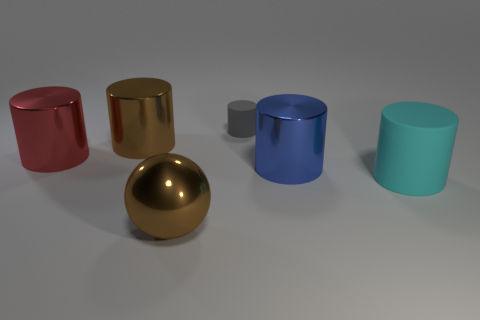The tiny gray rubber thing has what shape?
Offer a very short reply. Cylinder. What number of yellow balls are there?
Ensure brevity in your answer.  0. There is a large cylinder that is on the right side of the shiny cylinder that is right of the gray matte object; what color is it?
Provide a short and direct response. Cyan. There is a rubber cylinder that is the same size as the brown metal ball; what color is it?
Give a very brief answer. Cyan. Are there any objects of the same color as the big sphere?
Offer a very short reply. Yes. Is there a blue rubber cylinder?
Your answer should be compact. No. What shape is the rubber object that is behind the blue metal cylinder?
Provide a succinct answer. Cylinder. How many big cylinders are in front of the blue cylinder and on the left side of the large brown cylinder?
Your answer should be very brief. 0. How many other objects are there of the same size as the red metal cylinder?
Offer a terse response. 4. Is the shape of the rubber object behind the large brown metal cylinder the same as the big shiny thing that is to the right of the tiny cylinder?
Your response must be concise. Yes. 